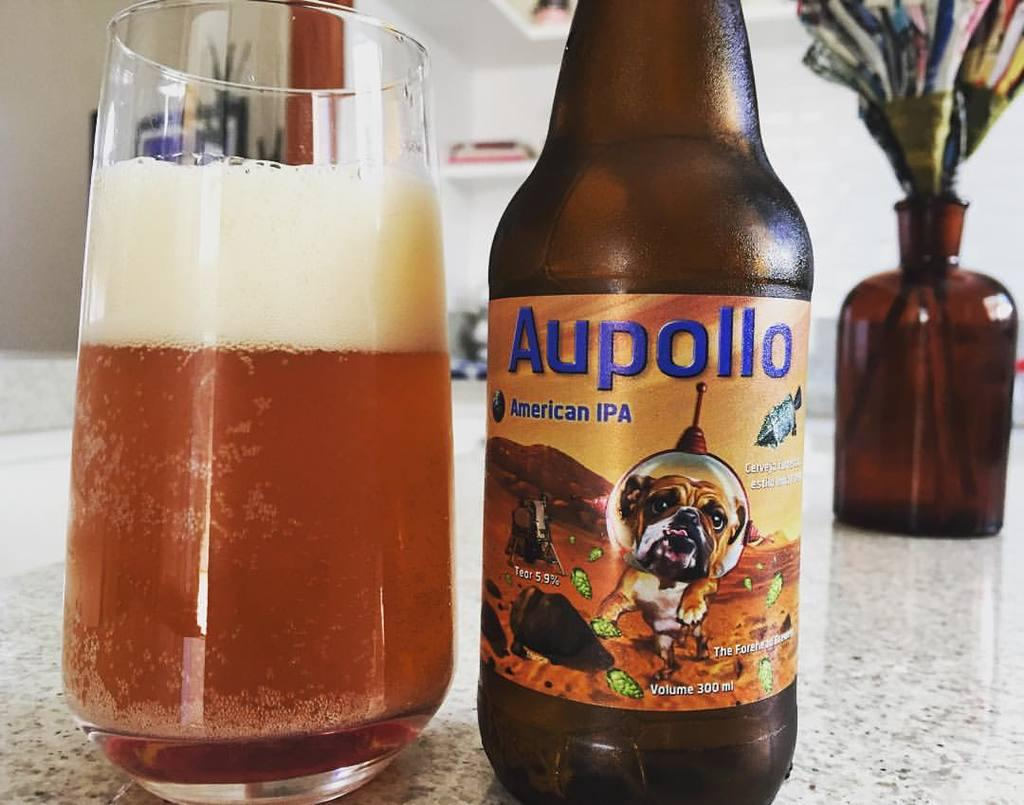<image>
Share a concise interpretation of the image provided. A bottle of Aupollo American IPA sits next to a glass. 